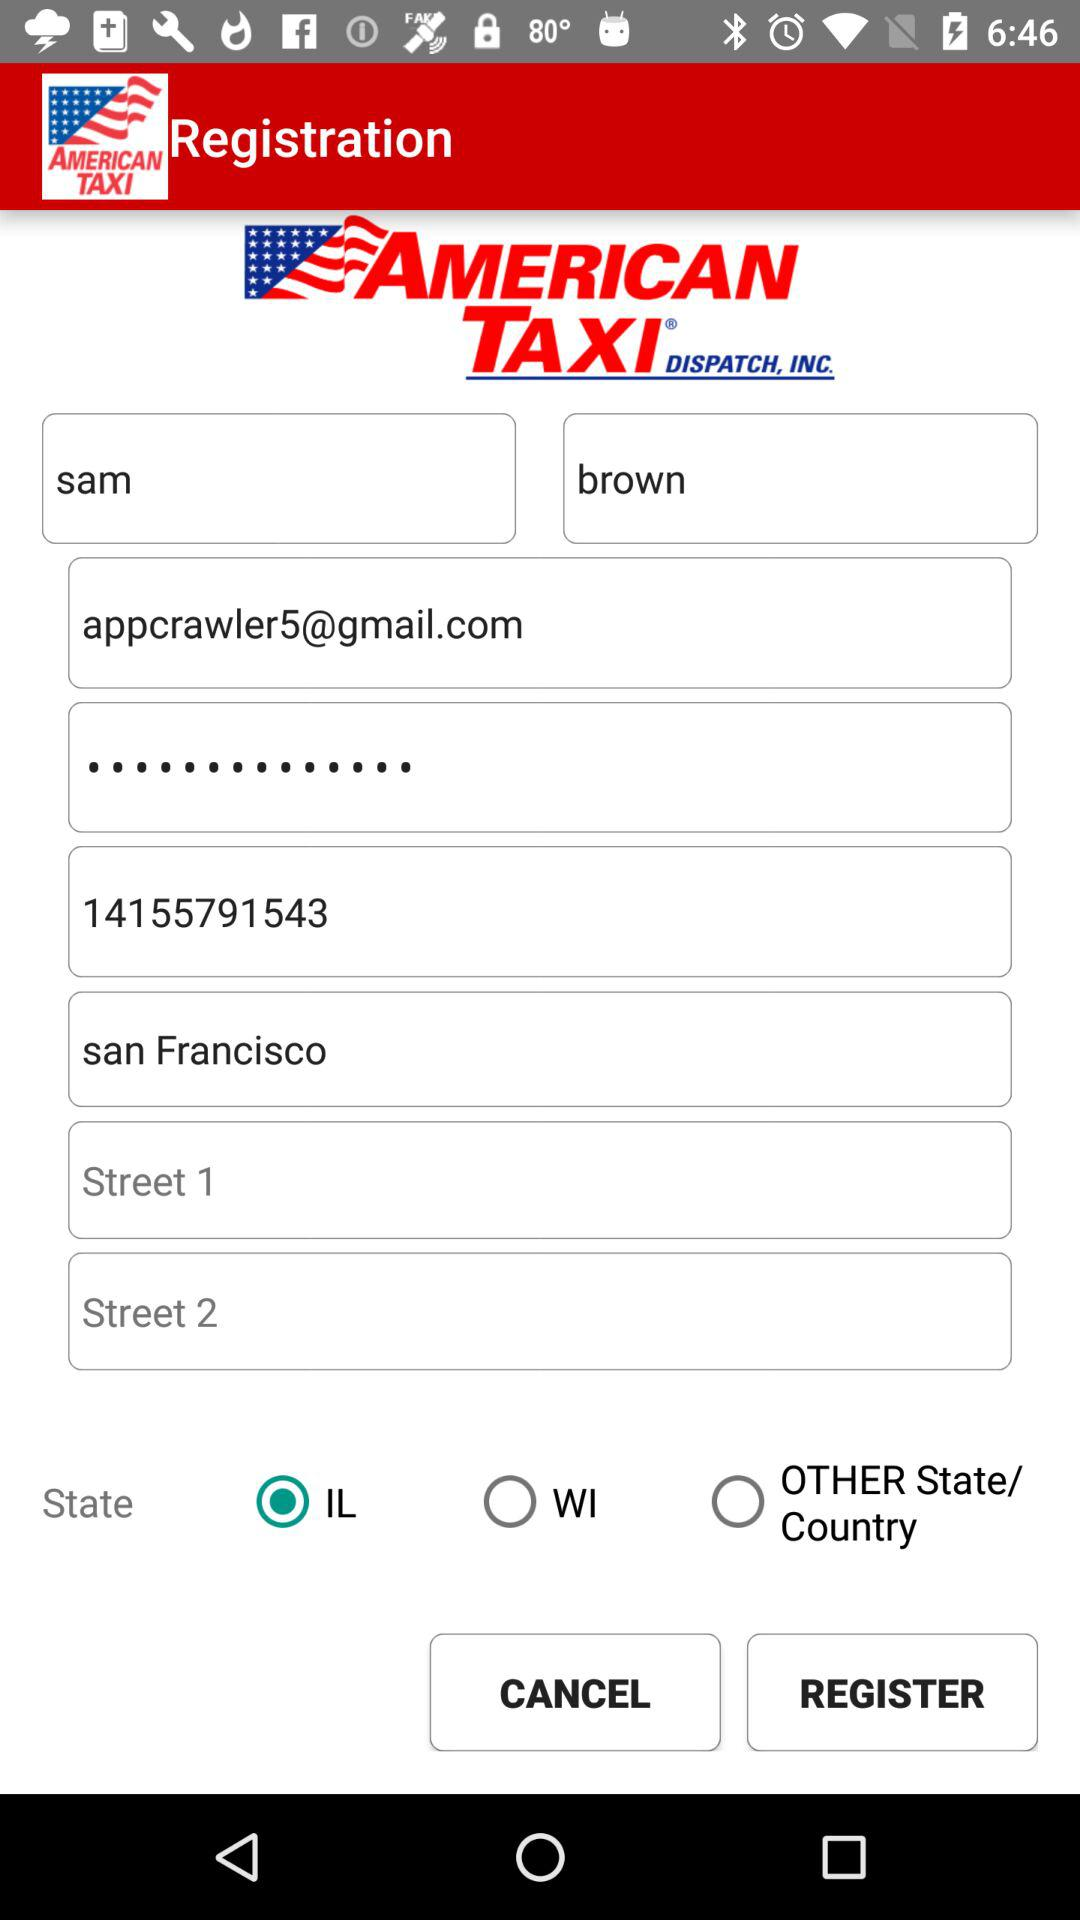What is the number shown on the screen? The number is 14155791543. 